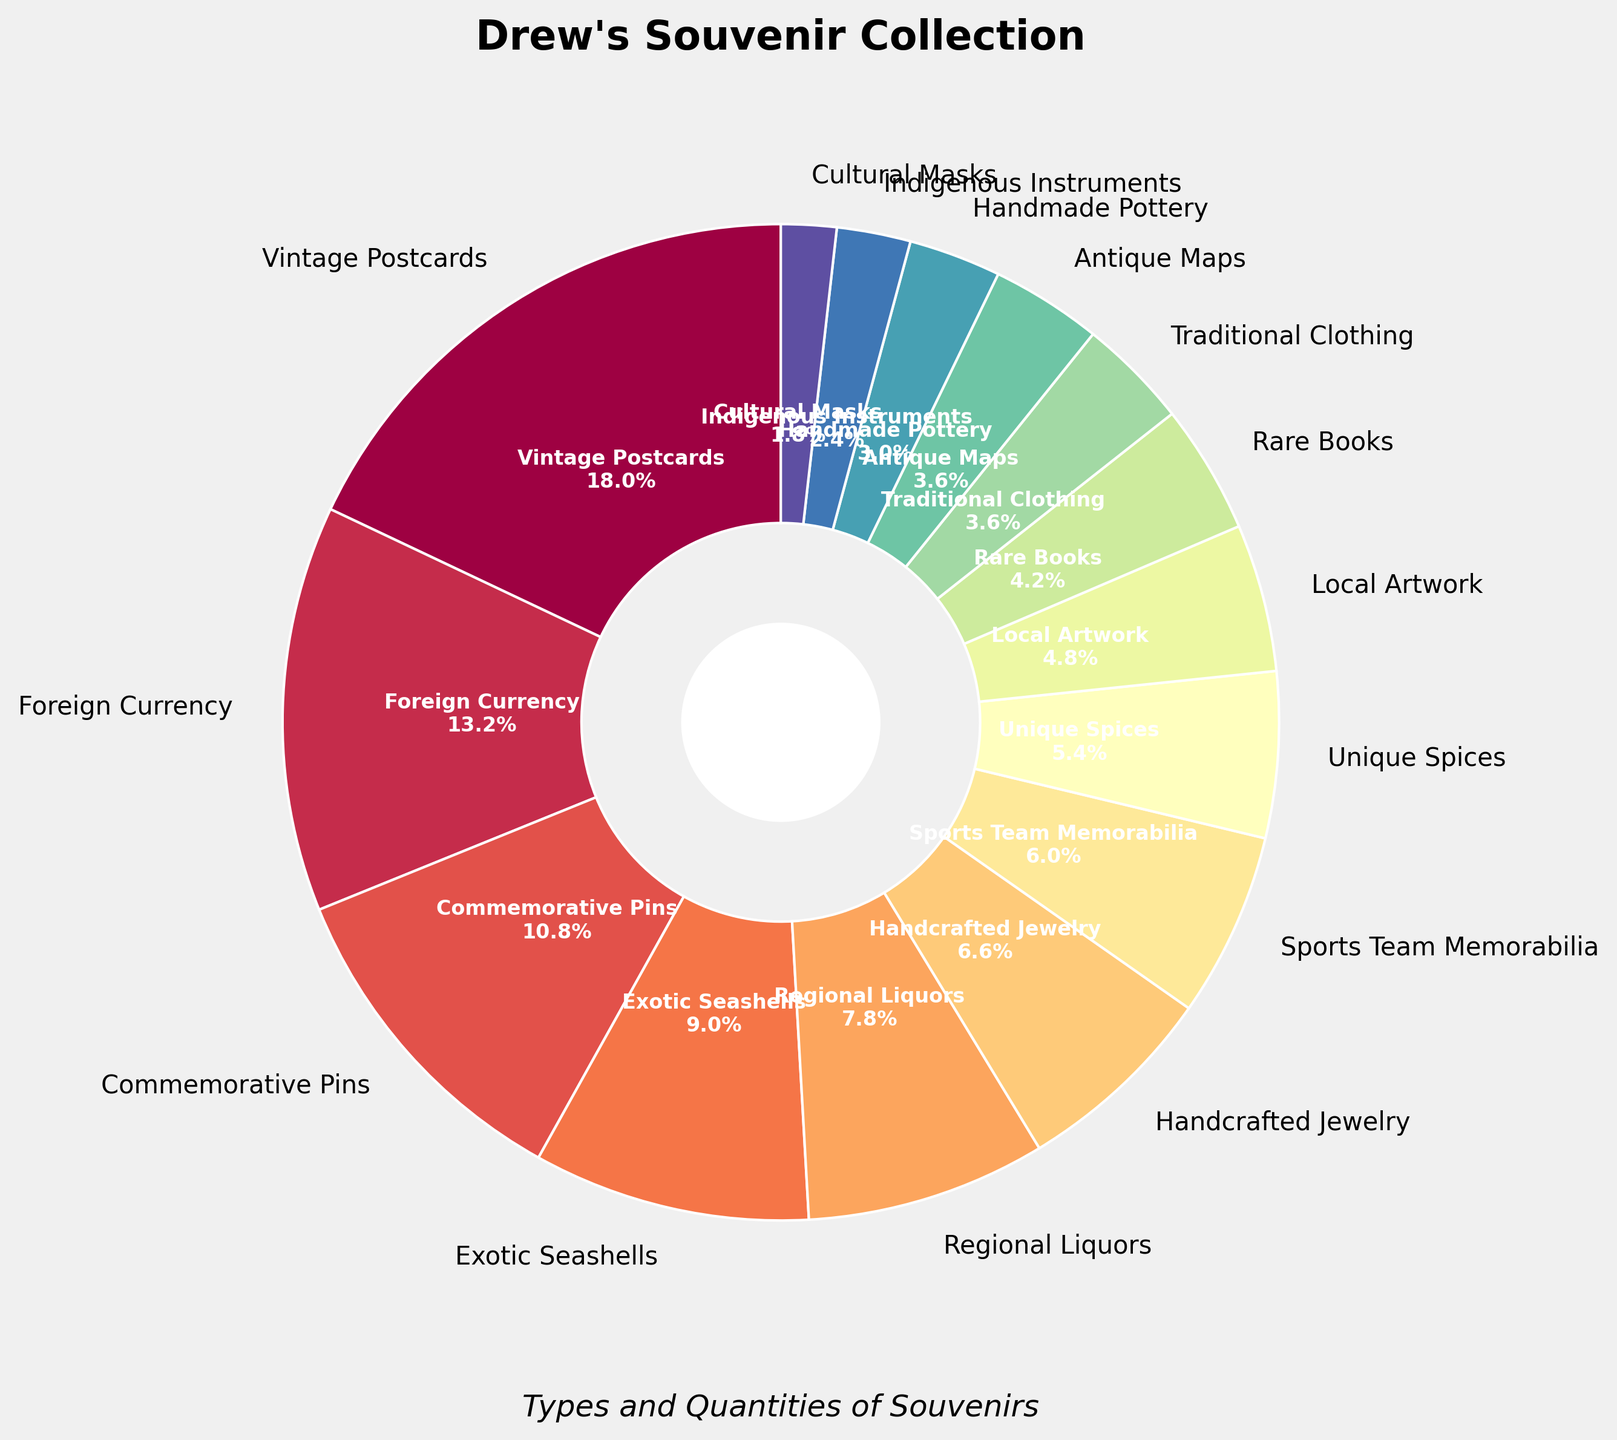Which type of souvenir does Drew collect the most? The figure shows different types of souvenirs with their quantities. By looking at the chart, "Vintage Postcards" has the largest segment.
Answer: Vintage Postcards How many more "Commemorative Pins" does Drew have compared to "Unique Spices"? From the pie chart, "Commemorative Pins" are 18 and "Unique Spices" are 9. The difference is 18 - 9.
Answer: 9 What is the total quantity of "Exotic Seashells" and "Handcrafted Jewelry"? The chart shows "Exotic Seashells" is 15 and "Handcrafted Jewelry" is 11. Their total is 15 + 11.
Answer: 26 Which souvenir type is represented by the smallest segment in the chart? The smallest segment in the pie chart corresponds to "Cultural Masks" with a quantity of 3.
Answer: Cultural Masks Compare the quantity of "Traditional Clothing" and "Antique Maps" and determine which is greater. "Traditional Clothing" has a quantity of 6, while "Antique Maps" also has 6; they are equal.
Answer: Equal What percentage of the total collection do "Sports Team Memorabilia" items count for? The percentage is shown next to each segment. "Sports Team Memorabilia" shows it makes up 7.5% of the collection.
Answer: 7.5% What is the difference between the smallest and the largest quantity of souvenirs? The smallest quantity is "Cultural Masks" (3), and the largest is "Vintage Postcards" (30). The difference is 30 - 3.
Answer: 27 Identify the segment with a quantity of 7 in the figure. By inspecting the pie chart, the segment with a quantity of 7 is "Rare Books".
Answer: Rare Books Which color represents "Regional Liquors" in the pie chart? Visual examination of the pie chart shows that "Regional Liquors" is represented by a certain color (e.g., purple or red, depending on the particular chart colors).
Answer: [Color identified from the chart] 